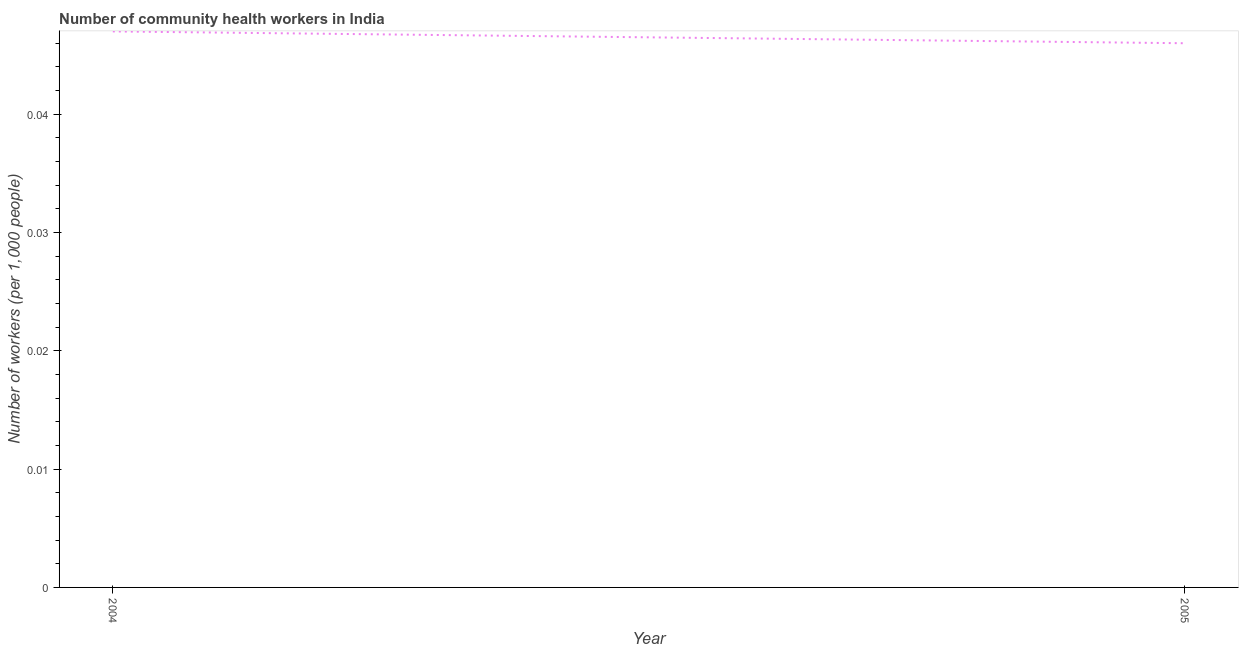What is the number of community health workers in 2005?
Your response must be concise. 0.05. Across all years, what is the maximum number of community health workers?
Your response must be concise. 0.05. Across all years, what is the minimum number of community health workers?
Ensure brevity in your answer.  0.05. What is the sum of the number of community health workers?
Ensure brevity in your answer.  0.09. What is the difference between the number of community health workers in 2004 and 2005?
Keep it short and to the point. 0. What is the average number of community health workers per year?
Give a very brief answer. 0.05. What is the median number of community health workers?
Your response must be concise. 0.05. In how many years, is the number of community health workers greater than 0.028 ?
Your answer should be compact. 2. Do a majority of the years between 2004 and 2005 (inclusive) have number of community health workers greater than 0.036 ?
Give a very brief answer. Yes. What is the ratio of the number of community health workers in 2004 to that in 2005?
Make the answer very short. 1.02. Is the number of community health workers in 2004 less than that in 2005?
Provide a succinct answer. No. Does the number of community health workers monotonically increase over the years?
Provide a short and direct response. No. How many lines are there?
Your response must be concise. 1. How many years are there in the graph?
Your response must be concise. 2. Are the values on the major ticks of Y-axis written in scientific E-notation?
Ensure brevity in your answer.  No. Does the graph contain any zero values?
Make the answer very short. No. Does the graph contain grids?
Offer a terse response. No. What is the title of the graph?
Ensure brevity in your answer.  Number of community health workers in India. What is the label or title of the X-axis?
Your answer should be very brief. Year. What is the label or title of the Y-axis?
Give a very brief answer. Number of workers (per 1,0 people). What is the Number of workers (per 1,000 people) in 2004?
Your response must be concise. 0.05. What is the Number of workers (per 1,000 people) in 2005?
Offer a very short reply. 0.05. 